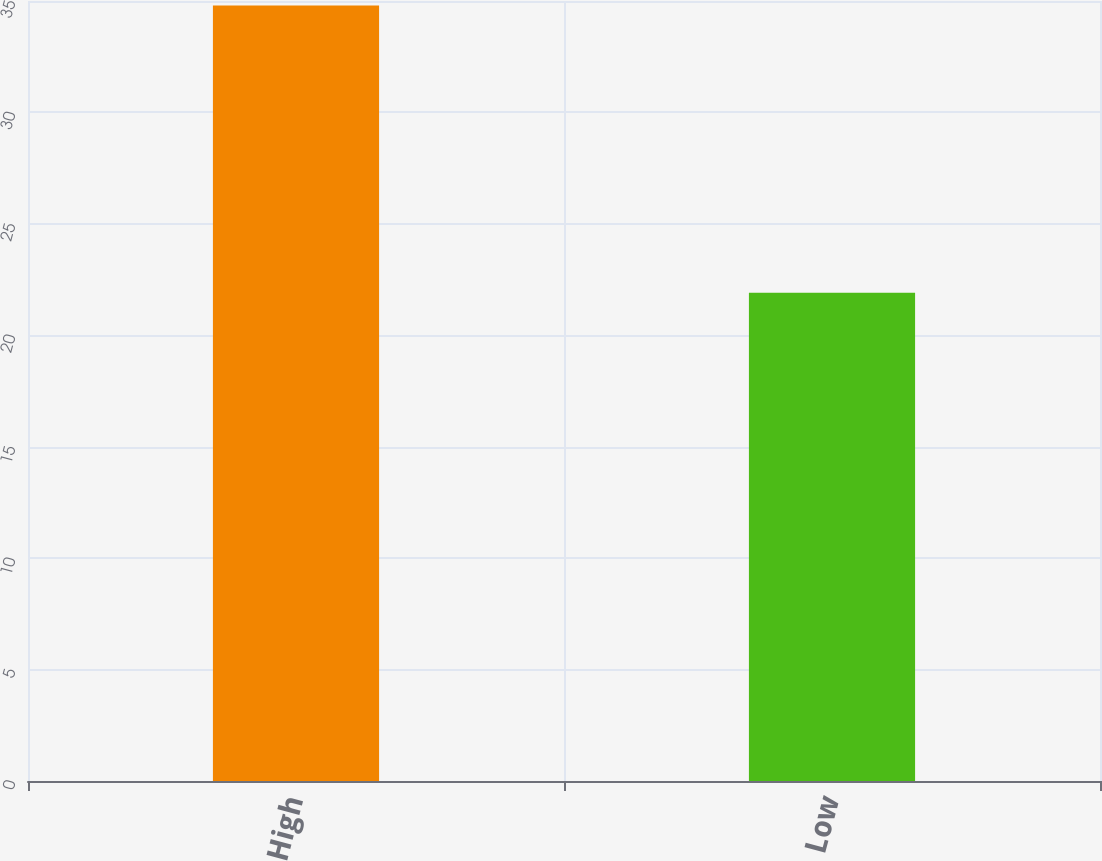Convert chart to OTSL. <chart><loc_0><loc_0><loc_500><loc_500><bar_chart><fcel>High<fcel>Low<nl><fcel>34.8<fcel>21.91<nl></chart> 